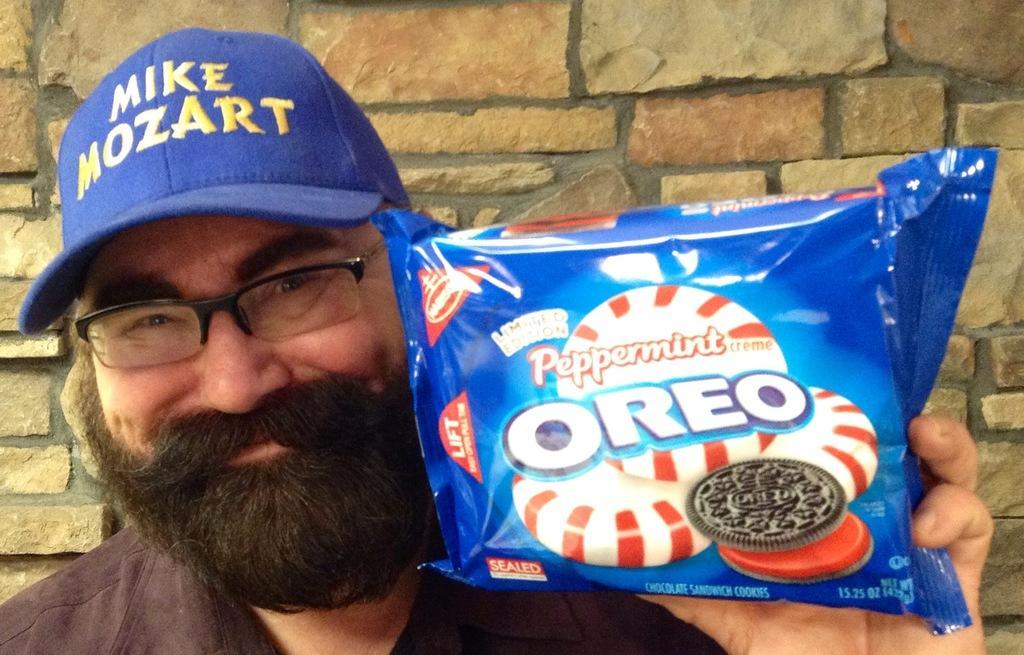Could you give a brief overview of what you see in this image? In this image we can see a man is holding a Oreo biscuit packet in his hand and there is a cap on his head. In the background we can see the wall. 